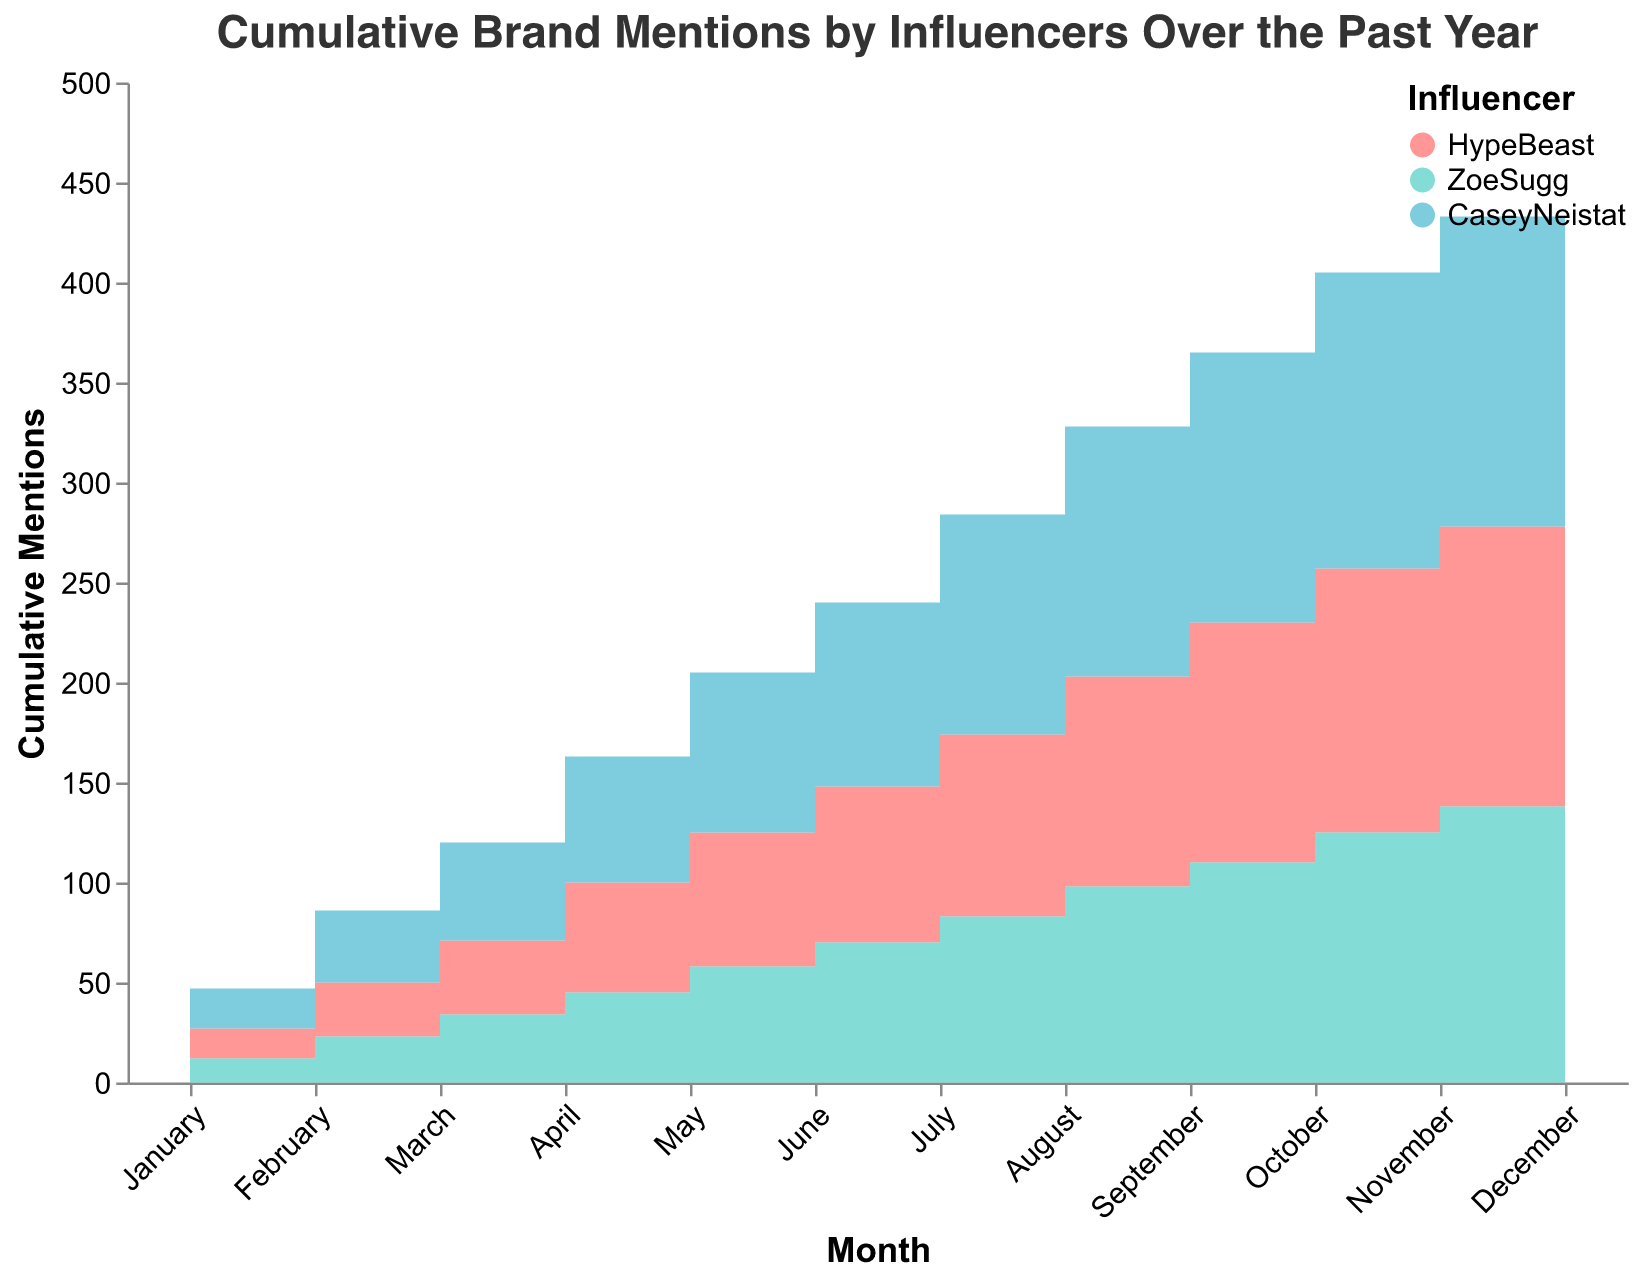What's the title of the chart? The title is at the top of the chart and provides a summary of the data represented.
Answer: Cumulative Brand Mentions by Influencers Over the Past Year Which influencer had the highest cumulative mentions in December? By observing the December data point for each influencer, Casey Neistat has the highest cumulative mentions.
Answer: Casey Neistat How many cumulative mentions did Zoe Sugg have in July? Locate the July data for Zoe Sugg in the chart. The cumulative mentions for Zoe Sugg in July is 83.
Answer: 83 Between HypeBeast and Casey Neistat, who had more mentions in the month of April? Compare the cumulative mentions in April for both HypeBeast (55) and Casey Neistat (63). Casey Neistat had more mentions.
Answer: Casey Neistat What's the total cumulative mentions of Adidas in August? Add the mentions of HypeBeast (105) and Zoe Sugg (98) for August to get the total cumulative mentions for Adidas: 105 + 98 = 203.
Answer: 203 Which month saw the largest increase in mentions for Nike by Casey Neistat compared to the previous month? Compare the cumulative mentions month over month for Nike. The largest increase appears to be from July (110) to August (125), an increase of 15 mentions.
Answer: August In which months did Zoe Sugg's cumulative mentions exactly equal 150? Find the months where Zoe Sugg's line intersects the 150 marks. This occurs only in December.
Answer: December Among the three influencers, who maintained the most consistent (least varied) growth in cumulative mentions throughout the year for their respective brand? By examining the smoothness and incremental nature of the step area plots, HypeBeast's plot for Adidas appears the most consistent with fewer drastic changes compared to Casey Neistat and Zoe Sugg.
Answer: HypeBeast What is the cumulative difference between HypeBeast and Zoe Sugg's mentions in December? Subtract Zoe Sugg's mentions (150) from HypeBeast's mentions (155) in December. The difference is 155 - 150 = 5.
Answer: 5 